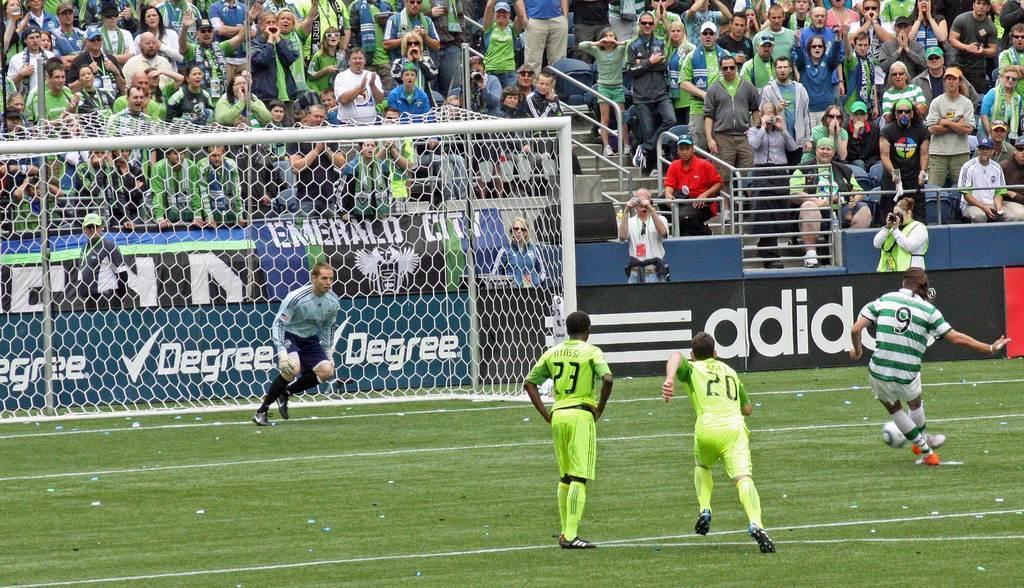In one or two sentences, can you explain what this image depicts? There are group of players playing football and there are audience in front of them and the ground is greenery. 